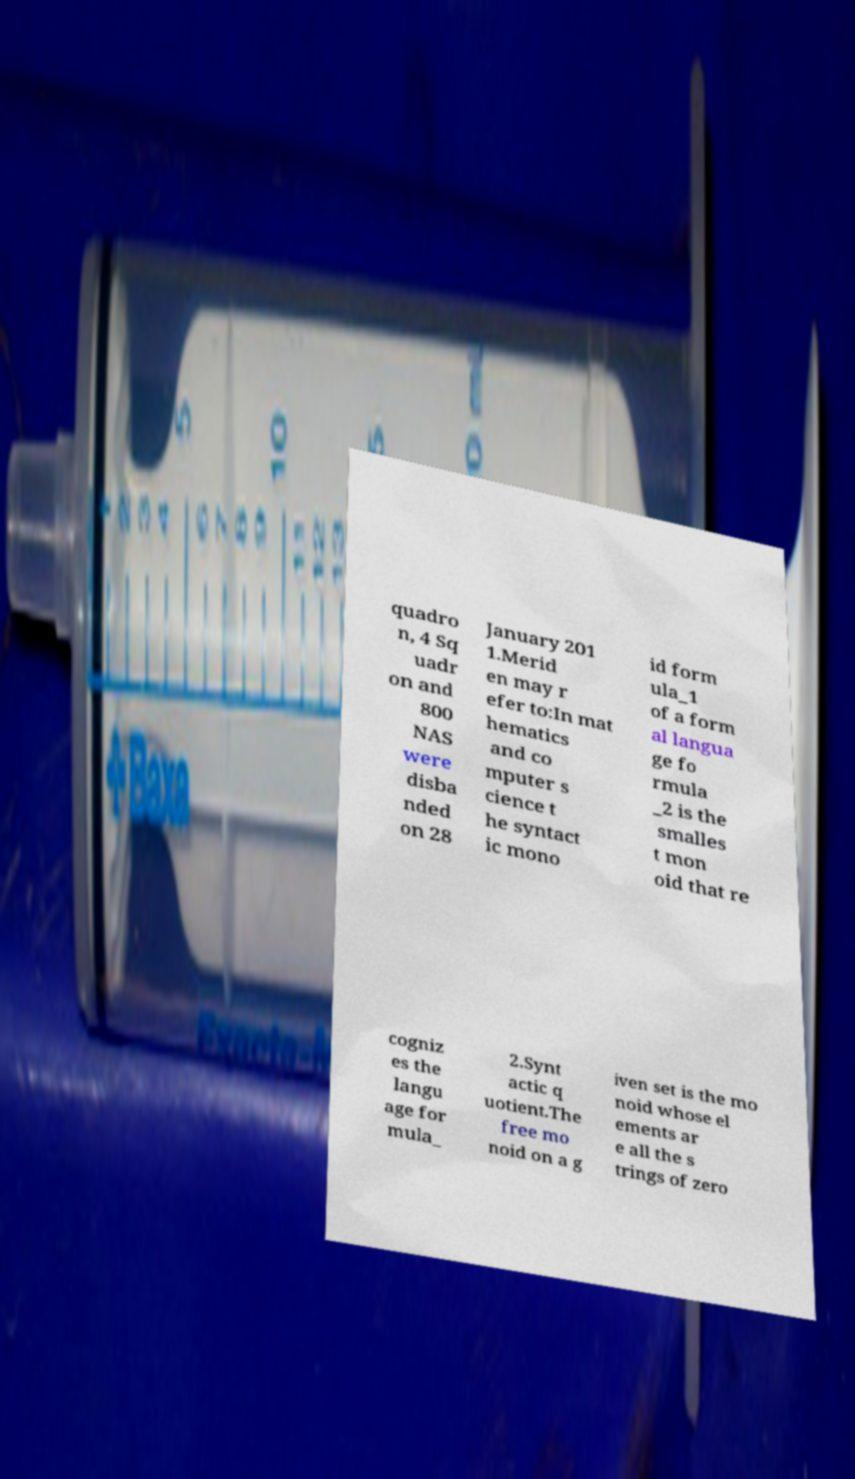Can you read and provide the text displayed in the image?This photo seems to have some interesting text. Can you extract and type it out for me? quadro n, 4 Sq uadr on and 800 NAS were disba nded on 28 January 201 1.Merid en may r efer to:In mat hematics and co mputer s cience t he syntact ic mono id form ula_1 of a form al langua ge fo rmula _2 is the smalles t mon oid that re cogniz es the langu age for mula_ 2.Synt actic q uotient.The free mo noid on a g iven set is the mo noid whose el ements ar e all the s trings of zero 